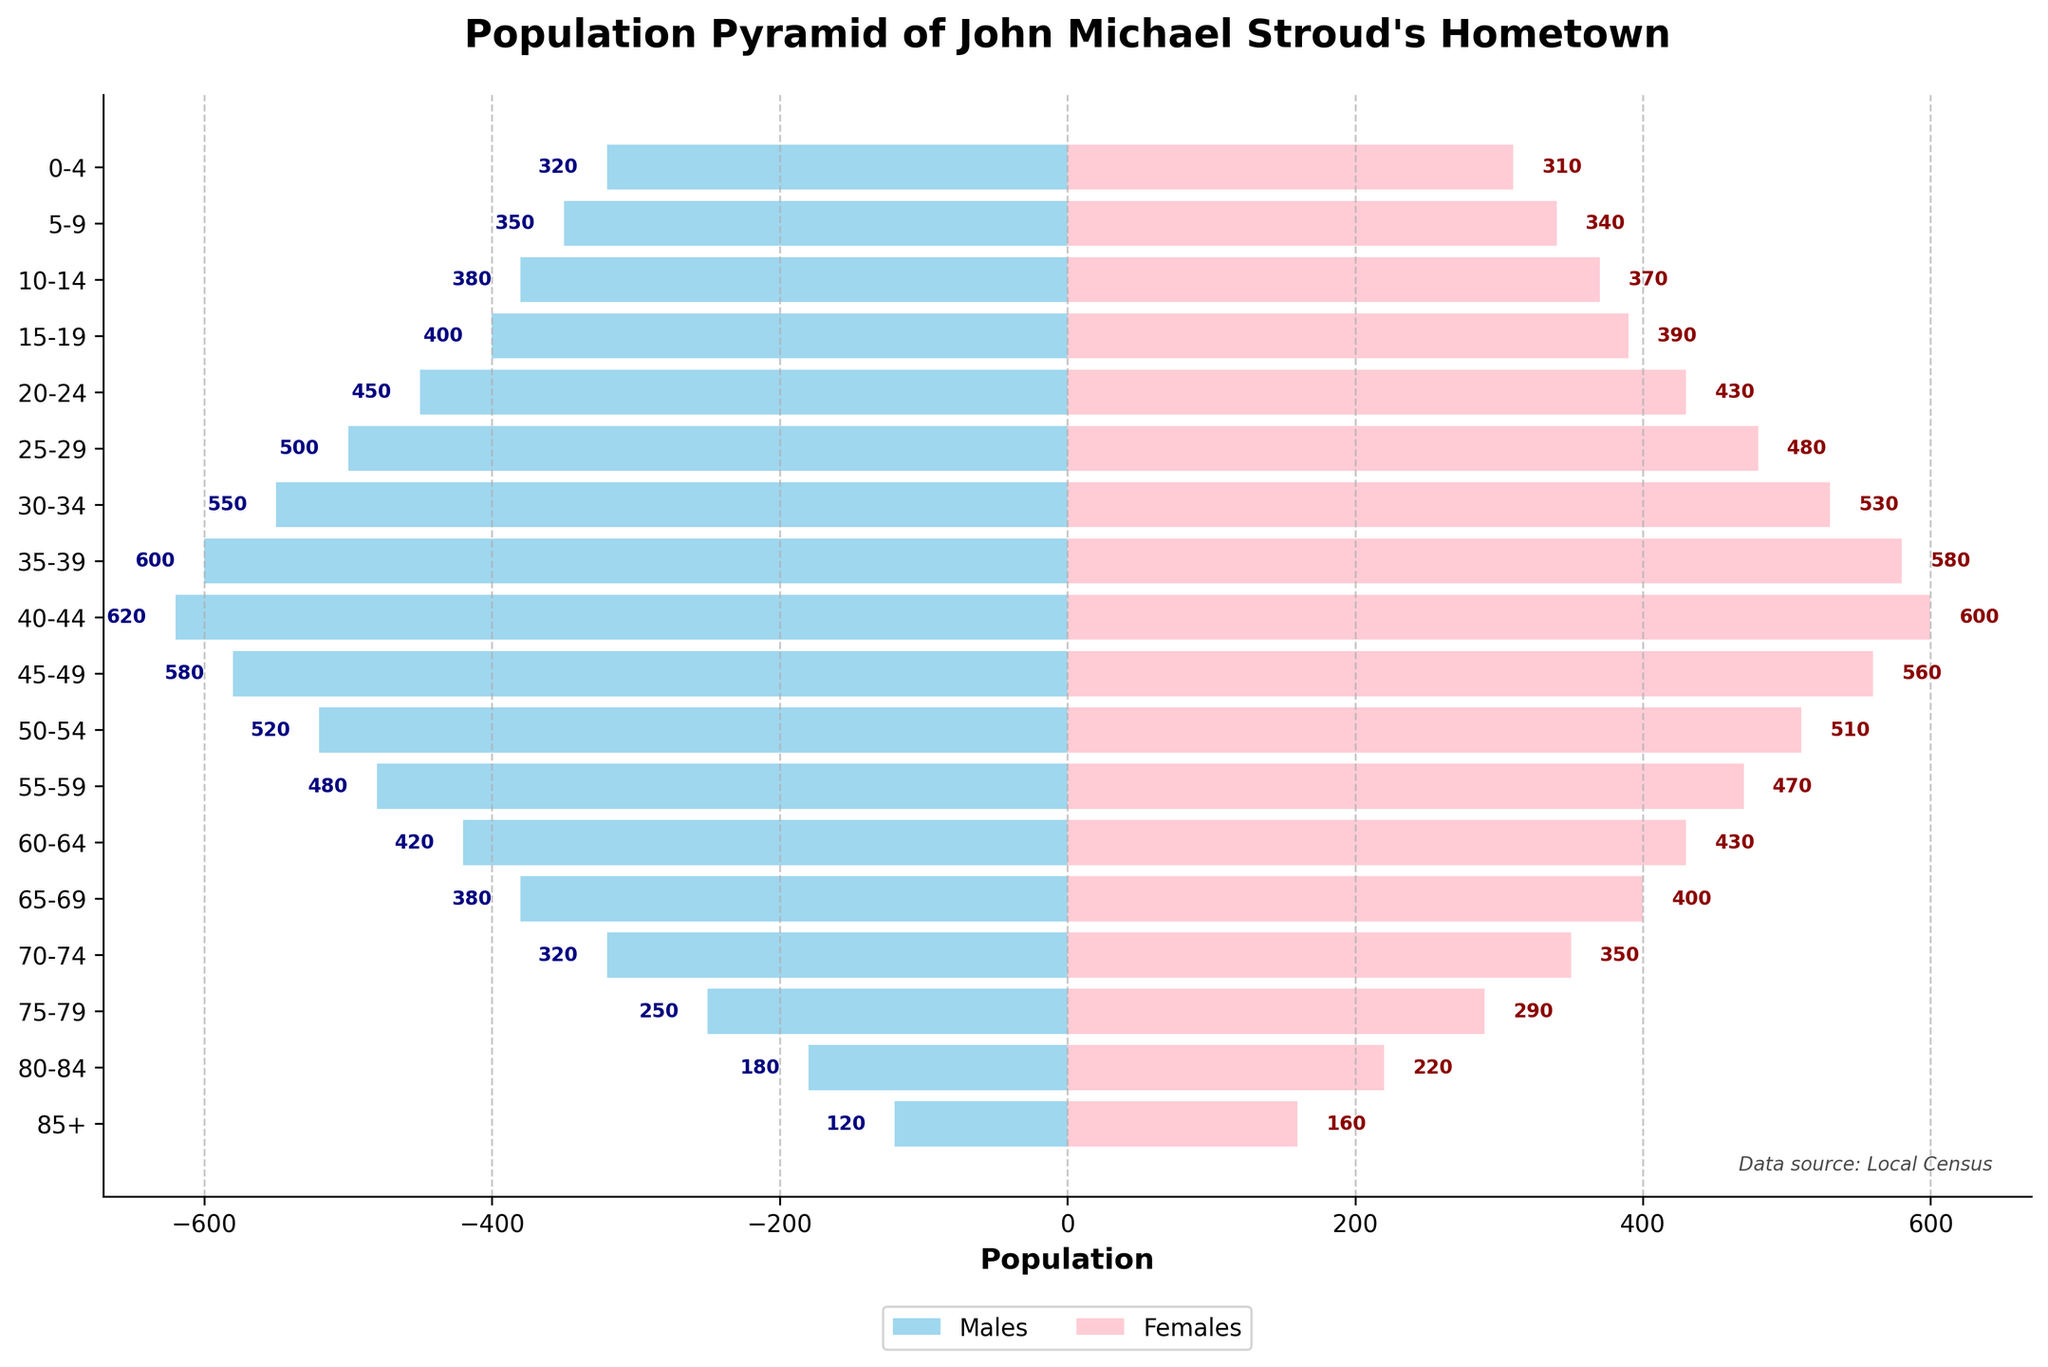What's the title of the figure? Look at the top of the figure where the title is displayed. This title is usually placed above the visual components.
Answer: "Population Pyramid of John Michael Stroud's Hometown" What is the population of males aged 30-34? Find the bar corresponding to the age group 30-34. The population of males is represented by the length of the bar to the left of the 0 line.
Answer: 550 Which age group has the highest total population? Sum the populations of males and females for each age group and compare the sums to find the highest one. The age group 40-44 has the highest populations for both genders combined.
  Calculation: (620 + 600 = 1220)
Answer: 40-44 How does the population of females aged 0-4 compare to that of males aged 0-4? Look at both bars for the age group 0-4. The male bar representing 320 and the female bar representing 310.
Answer: Males aged 0-4 have a higher population than females What is the total population for the age group 55-59? Sum the males and females' populations in the age group 55-59. Calculation: (480 for males) + (470 for females) = 950
Answer: 950 How does the male population of the 45-49 age group compare with the male population of the 20-24 age group? Compare the lengths of the bars for males in these age groups. 580 (45-49) versus 450 (20-24) shows that the 45-49 age group has more males.
Answer: 45-49 has more males Which gender has a higher population in the age group 85+? Look at the bars labeled 85+ and observe that the female bar is longer than the male bar, indicating a higher population.
Answer: Females What is the difference in population between males and females aged 10-14? Subtract the population of females from the population of males aged 10-14. Calculation: 380 (males) - 370 (females) = 10
Answer: 10 What is the general trend in the population as the age groups increase from 0-4 to 85+? Observe the lengths of the bars from bottom to top. There is an initial increase in population up to the age group 40-44, followed by a gradual decrease as the age increases further.
Answer: Increasing then decreasing Compare the population of males and females in the age group 35-39. Observe the lengths of the bars for males and females in the age group 35-39. The male bar represents 600 while the female bar represents 580, meaning the male population is higher.
Answer: Males have a higher population 